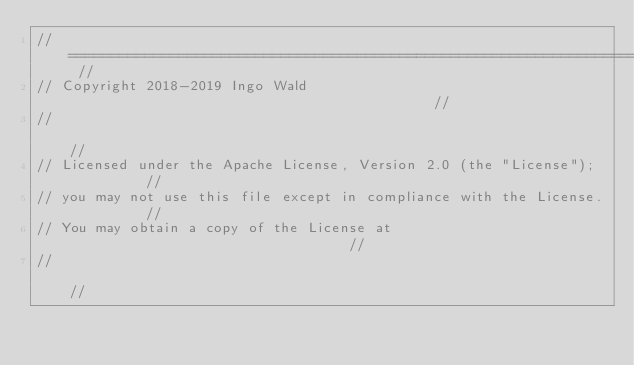<code> <loc_0><loc_0><loc_500><loc_500><_C++_>// ======================================================================== //
// Copyright 2018-2019 Ingo Wald                                            //
//                                                                          //
// Licensed under the Apache License, Version 2.0 (the "License");          //
// you may not use this file except in compliance with the License.         //
// You may obtain a copy of the License at                                  //
//                                                                          //</code> 